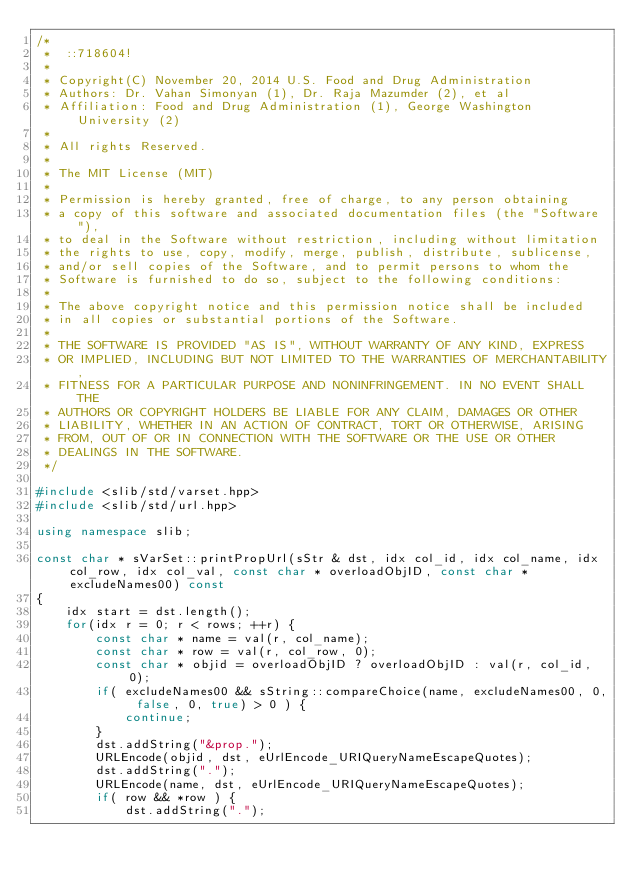<code> <loc_0><loc_0><loc_500><loc_500><_C++_>/*
 *  ::718604!
 * 
 * Copyright(C) November 20, 2014 U.S. Food and Drug Administration
 * Authors: Dr. Vahan Simonyan (1), Dr. Raja Mazumder (2), et al
 * Affiliation: Food and Drug Administration (1), George Washington University (2)
 * 
 * All rights Reserved.
 * 
 * The MIT License (MIT)
 * 
 * Permission is hereby granted, free of charge, to any person obtaining
 * a copy of this software and associated documentation files (the "Software"),
 * to deal in the Software without restriction, including without limitation
 * the rights to use, copy, modify, merge, publish, distribute, sublicense,
 * and/or sell copies of the Software, and to permit persons to whom the
 * Software is furnished to do so, subject to the following conditions:
 * 
 * The above copyright notice and this permission notice shall be included
 * in all copies or substantial portions of the Software.
 * 
 * THE SOFTWARE IS PROVIDED "AS IS", WITHOUT WARRANTY OF ANY KIND, EXPRESS
 * OR IMPLIED, INCLUDING BUT NOT LIMITED TO THE WARRANTIES OF MERCHANTABILITY,
 * FITNESS FOR A PARTICULAR PURPOSE AND NONINFRINGEMENT. IN NO EVENT SHALL THE
 * AUTHORS OR COPYRIGHT HOLDERS BE LIABLE FOR ANY CLAIM, DAMAGES OR OTHER
 * LIABILITY, WHETHER IN AN ACTION OF CONTRACT, TORT OR OTHERWISE, ARISING
 * FROM, OUT OF OR IN CONNECTION WITH THE SOFTWARE OR THE USE OR OTHER
 * DEALINGS IN THE SOFTWARE.
 */

#include <slib/std/varset.hpp>
#include <slib/std/url.hpp>

using namespace slib;

const char * sVarSet::printPropUrl(sStr & dst, idx col_id, idx col_name, idx col_row, idx col_val, const char * overloadObjID, const char * excludeNames00) const
{
    idx start = dst.length();
    for(idx r = 0; r < rows; ++r) {
        const char * name = val(r, col_name);
        const char * row = val(r, col_row, 0);
        const char * objid = overloadObjID ? overloadObjID : val(r, col_id, 0);
        if( excludeNames00 && sString::compareChoice(name, excludeNames00, 0, false, 0, true) > 0 ) {
            continue;
        }
        dst.addString("&prop.");
        URLEncode(objid, dst, eUrlEncode_URIQueryNameEscapeQuotes);
        dst.addString(".");
        URLEncode(name, dst, eUrlEncode_URIQueryNameEscapeQuotes);
        if( row && *row ) {
            dst.addString(".");</code> 